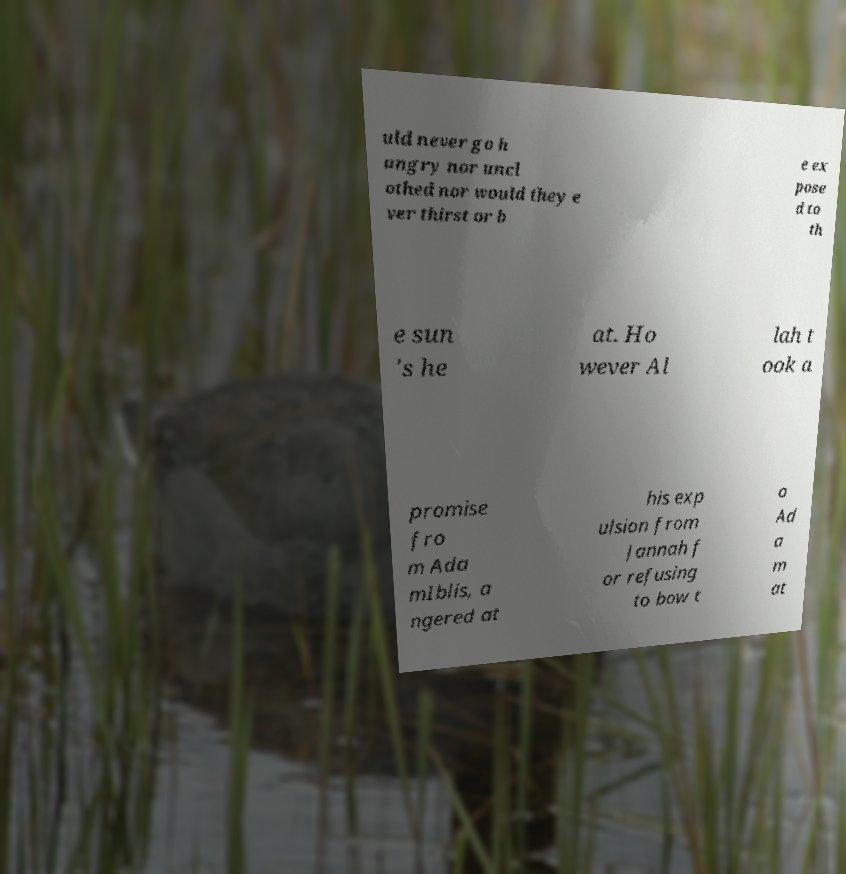Could you assist in decoding the text presented in this image and type it out clearly? uld never go h ungry nor uncl othed nor would they e ver thirst or b e ex pose d to th e sun 's he at. Ho wever Al lah t ook a promise fro m Ada mIblis, a ngered at his exp ulsion from Jannah f or refusing to bow t o Ad a m at 